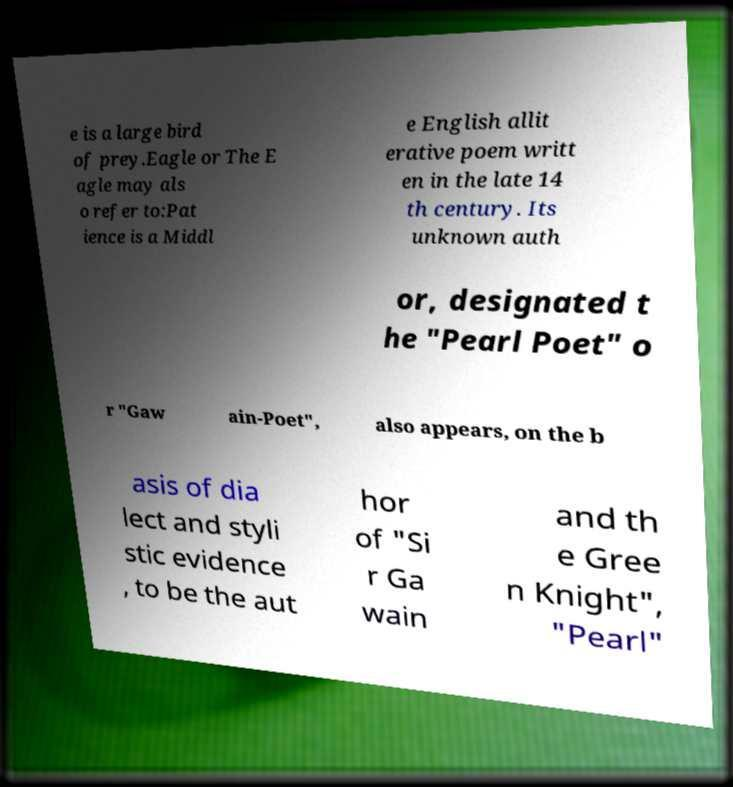What messages or text are displayed in this image? I need them in a readable, typed format. e is a large bird of prey.Eagle or The E agle may als o refer to:Pat ience is a Middl e English allit erative poem writt en in the late 14 th century. Its unknown auth or, designated t he "Pearl Poet" o r "Gaw ain-Poet", also appears, on the b asis of dia lect and styli stic evidence , to be the aut hor of "Si r Ga wain and th e Gree n Knight", "Pearl" 